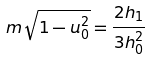Convert formula to latex. <formula><loc_0><loc_0><loc_500><loc_500>m \sqrt { 1 - u _ { 0 } ^ { 2 } } = \frac { 2 h _ { 1 } } { 3 h _ { 0 } ^ { 2 } }</formula> 